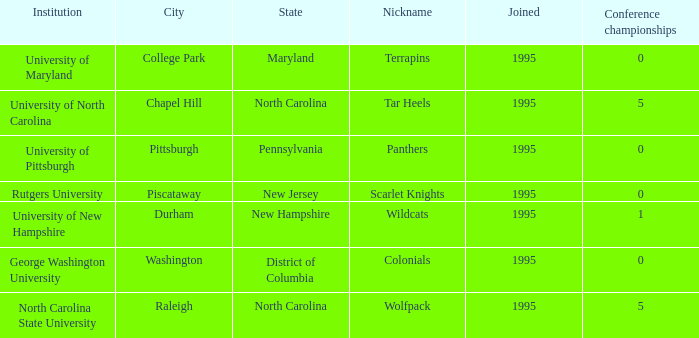What is the year joined with a Conference championships of 5, and a Nickname of wolfpack? 1995.0. 